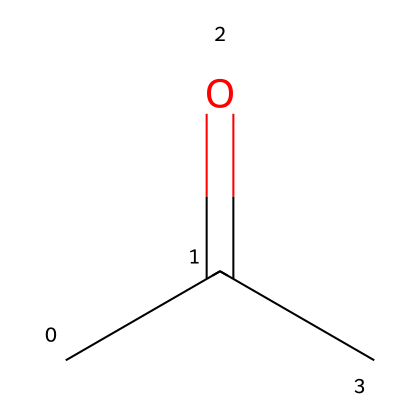What is the molecular formula of this chemical? The chemical structure represented by the SMILES CC(=O)C indicates that it contains three carbon (C) atoms, six hydrogen (H) atoms, and one oxygen (O) atom. Thus, the molecular formula is C3H6O.
Answer: C3H6O How many carbon atoms are in acetone? From the structure (CC(=O)C), there are three 'C' symbols, indicating the presence of three carbon atoms in the molecule.
Answer: 3 What functional group is present in this chemical? The presence of the carbonyl group (C=O) in the structure identifies the molecule as a ketone. The carbonyl carbon is bonded to two other carbon atoms, characteristic of ketones.
Answer: ketone Is the chemical flammable? Acetone is well-known for its flammability due to its low flash point and volatile nature, making it a highly flammable liquid.
Answer: yes What is the boiling point of acetone? Acetone has a boiling point of approximately 56 degrees Celsius, which is relatively low, and contributes to its volatility and flammability.
Answer: 56 degrees Celsius What type of reactions can acetone undergo? Acetone can undergo various reactions typical of ketones, such as nucleophilic addition and oxidation reactions, due to its structure.
Answer: nucleophilic addition, oxidation 